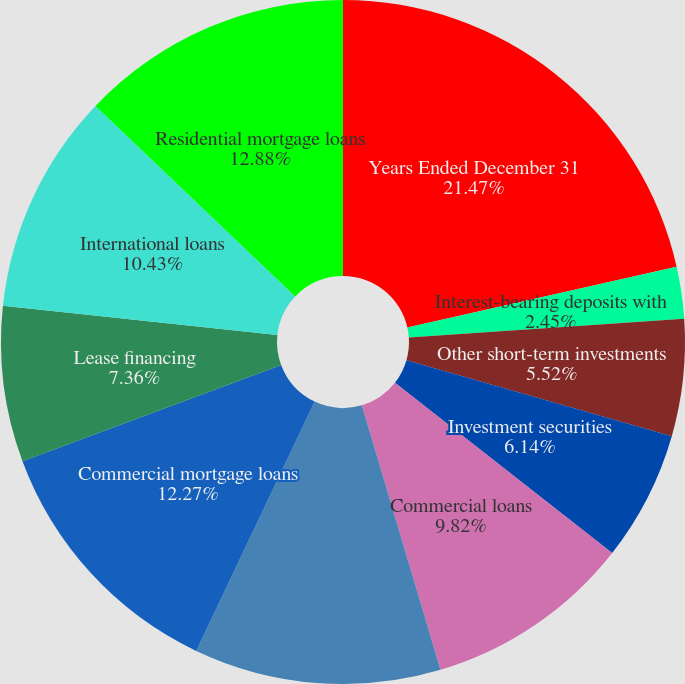Convert chart. <chart><loc_0><loc_0><loc_500><loc_500><pie_chart><fcel>Years Ended December 31<fcel>Interest-bearing deposits with<fcel>Other short-term investments<fcel>Investment securities<fcel>Commercial loans<fcel>Real estate construction loans<fcel>Commercial mortgage loans<fcel>Lease financing<fcel>International loans<fcel>Residential mortgage loans<nl><fcel>21.47%<fcel>2.45%<fcel>5.52%<fcel>6.14%<fcel>9.82%<fcel>11.66%<fcel>12.27%<fcel>7.36%<fcel>10.43%<fcel>12.88%<nl></chart> 